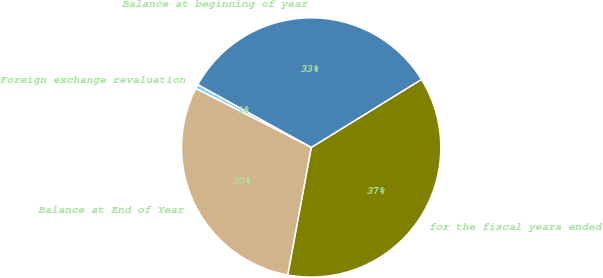<chart> <loc_0><loc_0><loc_500><loc_500><pie_chart><fcel>for the fiscal years ended<fcel>Balance at beginning of year<fcel>Foreign exchange revaluation<fcel>Balance at End of Year<nl><fcel>36.7%<fcel>33.16%<fcel>0.53%<fcel>29.62%<nl></chart> 